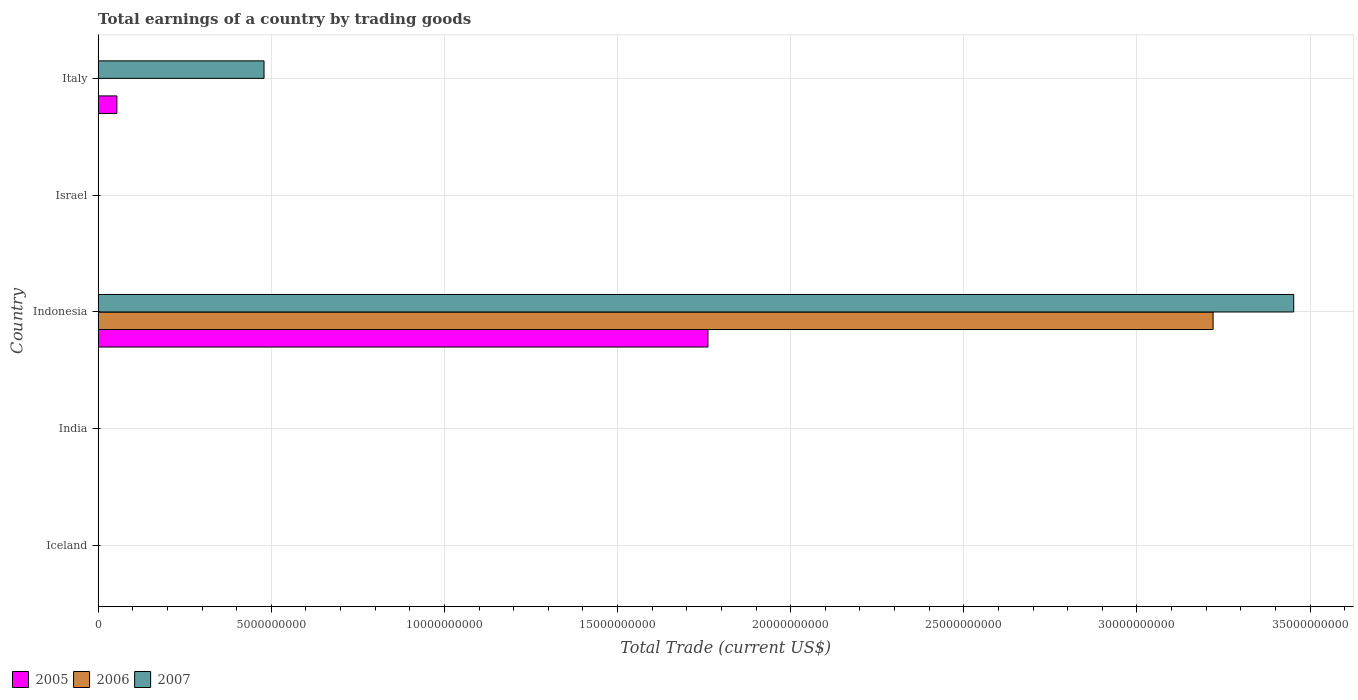Are the number of bars on each tick of the Y-axis equal?
Offer a very short reply. No. What is the label of the 4th group of bars from the top?
Your response must be concise. India. In how many cases, is the number of bars for a given country not equal to the number of legend labels?
Provide a short and direct response. 4. Across all countries, what is the maximum total earnings in 2006?
Offer a very short reply. 3.22e+1. Across all countries, what is the minimum total earnings in 2005?
Keep it short and to the point. 0. What is the total total earnings in 2005 in the graph?
Provide a short and direct response. 1.82e+1. What is the difference between the total earnings in 2005 in Italy and the total earnings in 2007 in Iceland?
Ensure brevity in your answer.  5.43e+08. What is the average total earnings in 2005 per country?
Your response must be concise. 3.63e+09. What is the difference between the total earnings in 2005 and total earnings in 2007 in Indonesia?
Your answer should be very brief. -1.69e+1. What is the ratio of the total earnings in 2005 in Indonesia to that in Italy?
Provide a short and direct response. 32.45. Is the difference between the total earnings in 2005 in Indonesia and Italy greater than the difference between the total earnings in 2007 in Indonesia and Italy?
Provide a short and direct response. No. What is the difference between the highest and the lowest total earnings in 2007?
Provide a succinct answer. 3.45e+1. Is it the case that in every country, the sum of the total earnings in 2007 and total earnings in 2005 is greater than the total earnings in 2006?
Provide a short and direct response. No. Are all the bars in the graph horizontal?
Provide a short and direct response. Yes. Does the graph contain any zero values?
Ensure brevity in your answer.  Yes. Does the graph contain grids?
Give a very brief answer. Yes. How are the legend labels stacked?
Your response must be concise. Horizontal. What is the title of the graph?
Offer a very short reply. Total earnings of a country by trading goods. What is the label or title of the X-axis?
Provide a short and direct response. Total Trade (current US$). What is the Total Trade (current US$) of 2006 in India?
Your answer should be compact. 0. What is the Total Trade (current US$) in 2005 in Indonesia?
Keep it short and to the point. 1.76e+1. What is the Total Trade (current US$) in 2006 in Indonesia?
Your answer should be compact. 3.22e+1. What is the Total Trade (current US$) in 2007 in Indonesia?
Give a very brief answer. 3.45e+1. What is the Total Trade (current US$) of 2005 in Israel?
Offer a terse response. 0. What is the Total Trade (current US$) of 2006 in Israel?
Provide a succinct answer. 0. What is the Total Trade (current US$) of 2007 in Israel?
Make the answer very short. 0. What is the Total Trade (current US$) in 2005 in Italy?
Offer a very short reply. 5.43e+08. What is the Total Trade (current US$) in 2006 in Italy?
Give a very brief answer. 0. What is the Total Trade (current US$) in 2007 in Italy?
Give a very brief answer. 4.79e+09. Across all countries, what is the maximum Total Trade (current US$) of 2005?
Provide a short and direct response. 1.76e+1. Across all countries, what is the maximum Total Trade (current US$) in 2006?
Ensure brevity in your answer.  3.22e+1. Across all countries, what is the maximum Total Trade (current US$) of 2007?
Give a very brief answer. 3.45e+1. Across all countries, what is the minimum Total Trade (current US$) of 2005?
Make the answer very short. 0. What is the total Total Trade (current US$) of 2005 in the graph?
Provide a short and direct response. 1.82e+1. What is the total Total Trade (current US$) in 2006 in the graph?
Keep it short and to the point. 3.22e+1. What is the total Total Trade (current US$) in 2007 in the graph?
Your response must be concise. 3.93e+1. What is the difference between the Total Trade (current US$) in 2005 in Indonesia and that in Italy?
Provide a succinct answer. 1.71e+1. What is the difference between the Total Trade (current US$) of 2007 in Indonesia and that in Italy?
Offer a terse response. 2.97e+1. What is the difference between the Total Trade (current US$) in 2005 in Indonesia and the Total Trade (current US$) in 2007 in Italy?
Give a very brief answer. 1.28e+1. What is the difference between the Total Trade (current US$) of 2006 in Indonesia and the Total Trade (current US$) of 2007 in Italy?
Offer a terse response. 2.74e+1. What is the average Total Trade (current US$) in 2005 per country?
Offer a terse response. 3.63e+09. What is the average Total Trade (current US$) in 2006 per country?
Your answer should be compact. 6.44e+09. What is the average Total Trade (current US$) in 2007 per country?
Ensure brevity in your answer.  7.86e+09. What is the difference between the Total Trade (current US$) in 2005 and Total Trade (current US$) in 2006 in Indonesia?
Offer a very short reply. -1.46e+1. What is the difference between the Total Trade (current US$) of 2005 and Total Trade (current US$) of 2007 in Indonesia?
Make the answer very short. -1.69e+1. What is the difference between the Total Trade (current US$) of 2006 and Total Trade (current US$) of 2007 in Indonesia?
Offer a terse response. -2.33e+09. What is the difference between the Total Trade (current US$) of 2005 and Total Trade (current US$) of 2007 in Italy?
Offer a terse response. -4.25e+09. What is the ratio of the Total Trade (current US$) in 2005 in Indonesia to that in Italy?
Make the answer very short. 32.45. What is the ratio of the Total Trade (current US$) of 2007 in Indonesia to that in Italy?
Your answer should be very brief. 7.21. What is the difference between the highest and the lowest Total Trade (current US$) of 2005?
Your response must be concise. 1.76e+1. What is the difference between the highest and the lowest Total Trade (current US$) in 2006?
Ensure brevity in your answer.  3.22e+1. What is the difference between the highest and the lowest Total Trade (current US$) of 2007?
Your answer should be very brief. 3.45e+1. 